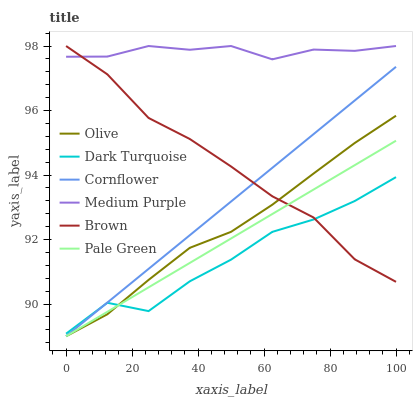Does Dark Turquoise have the minimum area under the curve?
Answer yes or no. Yes. Does Medium Purple have the maximum area under the curve?
Answer yes or no. Yes. Does Cornflower have the minimum area under the curve?
Answer yes or no. No. Does Cornflower have the maximum area under the curve?
Answer yes or no. No. Is Pale Green the smoothest?
Answer yes or no. Yes. Is Dark Turquoise the roughest?
Answer yes or no. Yes. Is Cornflower the smoothest?
Answer yes or no. No. Is Cornflower the roughest?
Answer yes or no. No. Does Dark Turquoise have the lowest value?
Answer yes or no. No. Does Cornflower have the highest value?
Answer yes or no. No. Is Dark Turquoise less than Medium Purple?
Answer yes or no. Yes. Is Medium Purple greater than Olive?
Answer yes or no. Yes. Does Dark Turquoise intersect Medium Purple?
Answer yes or no. No. 